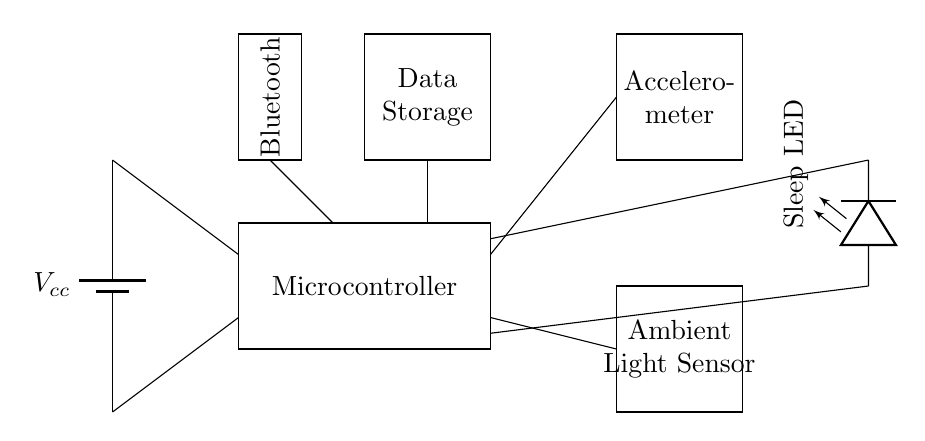What components are included in this circuit? The main components are a microcontroller, accelerometer, ambient light sensor, data storage, Bluetooth module, and a sleep indicator LED. Each component is represented as a rectangle in the circuit diagram.
Answer: microcontroller, accelerometer, ambient light sensor, data storage, Bluetooth module, sleep indicator LED How many sensors are present in this circuit? There are two sensors in the circuit: the accelerometer and the ambient light sensor. Each sensor is indicated by its own rectangle in the diagram.
Answer: two What does the sleep indicator LED represent? The sleep indicator LED is used to show the sleep status of the device. It lights up when the user is sleeping, providing a visual indication of the sleep state.
Answer: sleep status Which component is directly connected to the power supply? The microcontroller is directly connected to the power supply, which is represented by a battery. The connection is shown between the power source and the microcontroller in the circuit diagram.
Answer: microcontroller What is the purpose of the Bluetooth module in this circuit? The Bluetooth module enables wireless data communication, allowing the sleep monitoring device to transfer collected data to a mobile device or another system. This connectivity aids in remote monitoring.
Answer: wireless data communication How does the accelerometer contribute to sleep quality monitoring? The accelerometer detects movement and orientation, which can be used to analyze sleep patterns and restlessness during sleep, providing valuable data for assessing sleep quality.
Answer: detects movement What type of data storage is depicted in the circuit? The data storage component is used to store the sleep-related data collected by the sensors, allowing for future analysis and tracking of sleep patterns over time.
Answer: store sleep data 